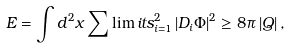Convert formula to latex. <formula><loc_0><loc_0><loc_500><loc_500>E = \int d ^ { 2 } x \sum \lim i t s _ { i = 1 } ^ { 2 } \left | D _ { i } \Phi \right | ^ { 2 } \geq 8 \pi \left | Q \right | ,</formula> 